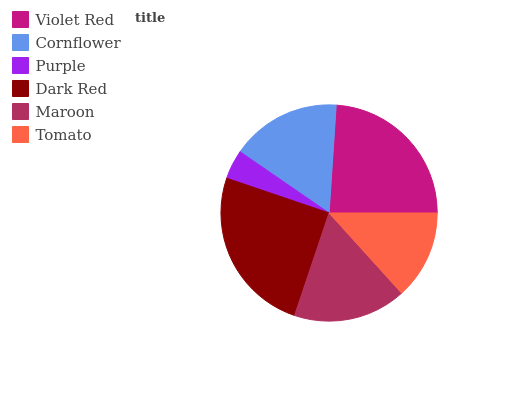Is Purple the minimum?
Answer yes or no. Yes. Is Dark Red the maximum?
Answer yes or no. Yes. Is Cornflower the minimum?
Answer yes or no. No. Is Cornflower the maximum?
Answer yes or no. No. Is Violet Red greater than Cornflower?
Answer yes or no. Yes. Is Cornflower less than Violet Red?
Answer yes or no. Yes. Is Cornflower greater than Violet Red?
Answer yes or no. No. Is Violet Red less than Cornflower?
Answer yes or no. No. Is Maroon the high median?
Answer yes or no. Yes. Is Cornflower the low median?
Answer yes or no. Yes. Is Purple the high median?
Answer yes or no. No. Is Tomato the low median?
Answer yes or no. No. 